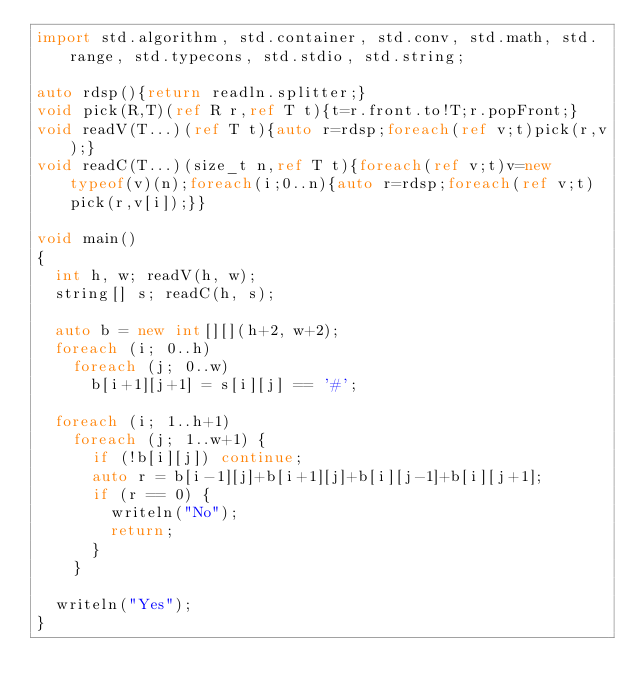Convert code to text. <code><loc_0><loc_0><loc_500><loc_500><_D_>import std.algorithm, std.container, std.conv, std.math, std.range, std.typecons, std.stdio, std.string;

auto rdsp(){return readln.splitter;}
void pick(R,T)(ref R r,ref T t){t=r.front.to!T;r.popFront;}
void readV(T...)(ref T t){auto r=rdsp;foreach(ref v;t)pick(r,v);}
void readC(T...)(size_t n,ref T t){foreach(ref v;t)v=new typeof(v)(n);foreach(i;0..n){auto r=rdsp;foreach(ref v;t)pick(r,v[i]);}}

void main()
{
  int h, w; readV(h, w);
  string[] s; readC(h, s);

  auto b = new int[][](h+2, w+2);
  foreach (i; 0..h)
    foreach (j; 0..w)
      b[i+1][j+1] = s[i][j] == '#';

  foreach (i; 1..h+1)
    foreach (j; 1..w+1) {
      if (!b[i][j]) continue;
      auto r = b[i-1][j]+b[i+1][j]+b[i][j-1]+b[i][j+1];
      if (r == 0) {
        writeln("No");
        return;
      }
    }

  writeln("Yes");
}
</code> 